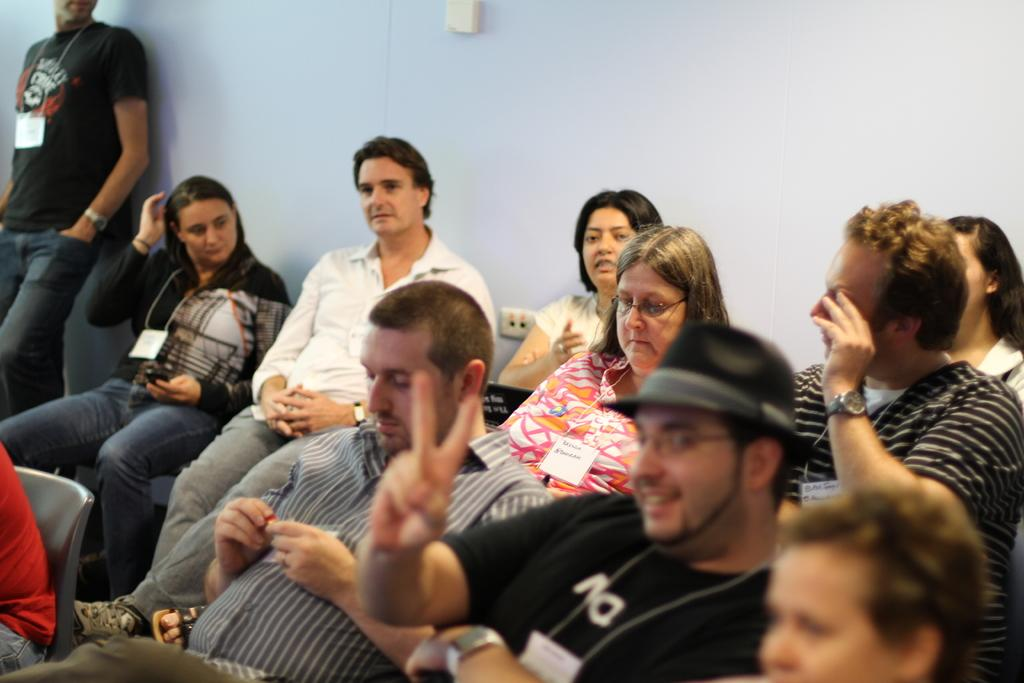What is the primary activity of the people in the image? The people in the image are sitting on chairs. Can you describe the position of the person standing in the image? The person standing is on the left side of the image. What is the person standing near in the image? The person standing is near a wall. What can be seen in the background of the image? There is a wall visible in the background of the image. What type of food is being served to the crowd in the image? There is no mention of a crowd or food in the image; it primarily features people sitting on chairs and a person standing near a wall. 